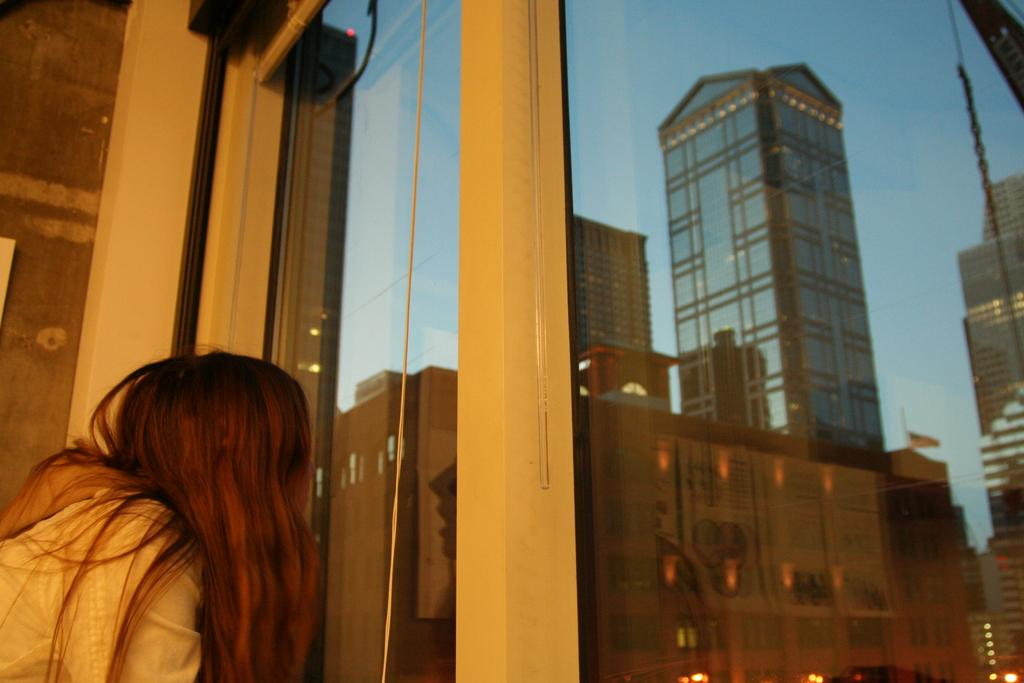What is the person in the image doing? There is a person at the window in the image. What can be seen in the distance in the image? There are buildings visible in the image. What is the flag associated with in the image? There is a flag in the image. What type of illumination is present in the image? There are lights in the image. What is visible in the background of the image? The sky is visible in the background of the image. What type of bone can be seen sticking out of the person's head in the image? There is no bone visible in the image, nor is there any indication that the person has a bone sticking out of their head. 